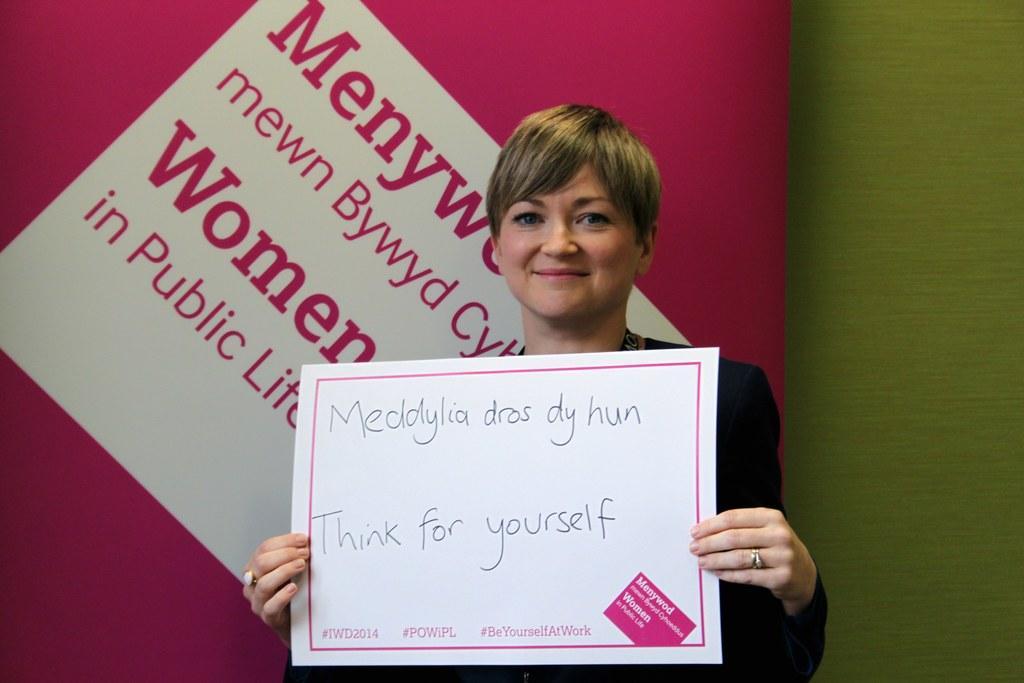Can you describe this image briefly? In this image there is a woman holding a placard in her hand is having a smile on her face, behind the woman there is some text on the wall. 